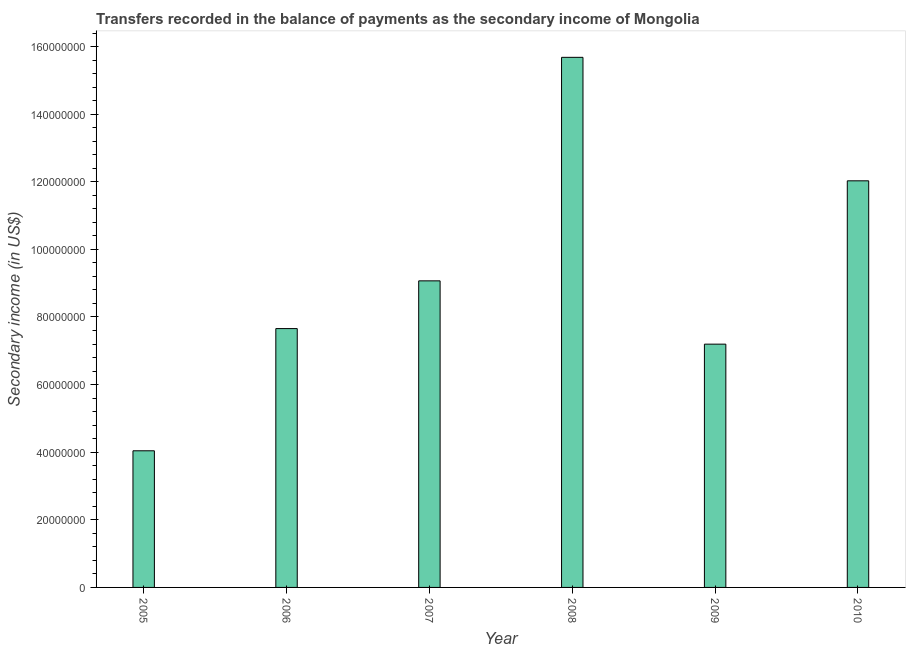Does the graph contain grids?
Provide a succinct answer. No. What is the title of the graph?
Keep it short and to the point. Transfers recorded in the balance of payments as the secondary income of Mongolia. What is the label or title of the X-axis?
Provide a succinct answer. Year. What is the label or title of the Y-axis?
Your answer should be very brief. Secondary income (in US$). What is the amount of secondary income in 2008?
Make the answer very short. 1.57e+08. Across all years, what is the maximum amount of secondary income?
Make the answer very short. 1.57e+08. Across all years, what is the minimum amount of secondary income?
Keep it short and to the point. 4.04e+07. In which year was the amount of secondary income maximum?
Give a very brief answer. 2008. In which year was the amount of secondary income minimum?
Your answer should be compact. 2005. What is the sum of the amount of secondary income?
Your answer should be compact. 5.57e+08. What is the difference between the amount of secondary income in 2005 and 2008?
Your answer should be very brief. -1.16e+08. What is the average amount of secondary income per year?
Keep it short and to the point. 9.28e+07. What is the median amount of secondary income?
Keep it short and to the point. 8.36e+07. Do a majority of the years between 2009 and 2007 (inclusive) have amount of secondary income greater than 40000000 US$?
Give a very brief answer. Yes. What is the ratio of the amount of secondary income in 2008 to that in 2010?
Provide a short and direct response. 1.3. Is the amount of secondary income in 2005 less than that in 2007?
Provide a succinct answer. Yes. Is the difference between the amount of secondary income in 2005 and 2006 greater than the difference between any two years?
Ensure brevity in your answer.  No. What is the difference between the highest and the second highest amount of secondary income?
Make the answer very short. 3.65e+07. What is the difference between the highest and the lowest amount of secondary income?
Keep it short and to the point. 1.16e+08. In how many years, is the amount of secondary income greater than the average amount of secondary income taken over all years?
Offer a terse response. 2. How many bars are there?
Make the answer very short. 6. Are all the bars in the graph horizontal?
Offer a very short reply. No. How many years are there in the graph?
Your answer should be compact. 6. Are the values on the major ticks of Y-axis written in scientific E-notation?
Keep it short and to the point. No. What is the Secondary income (in US$) in 2005?
Your response must be concise. 4.04e+07. What is the Secondary income (in US$) of 2006?
Offer a very short reply. 7.66e+07. What is the Secondary income (in US$) in 2007?
Make the answer very short. 9.07e+07. What is the Secondary income (in US$) in 2008?
Keep it short and to the point. 1.57e+08. What is the Secondary income (in US$) in 2009?
Make the answer very short. 7.20e+07. What is the Secondary income (in US$) of 2010?
Your answer should be compact. 1.20e+08. What is the difference between the Secondary income (in US$) in 2005 and 2006?
Your response must be concise. -3.62e+07. What is the difference between the Secondary income (in US$) in 2005 and 2007?
Offer a very short reply. -5.03e+07. What is the difference between the Secondary income (in US$) in 2005 and 2008?
Make the answer very short. -1.16e+08. What is the difference between the Secondary income (in US$) in 2005 and 2009?
Give a very brief answer. -3.15e+07. What is the difference between the Secondary income (in US$) in 2005 and 2010?
Offer a very short reply. -7.99e+07. What is the difference between the Secondary income (in US$) in 2006 and 2007?
Give a very brief answer. -1.41e+07. What is the difference between the Secondary income (in US$) in 2006 and 2008?
Provide a succinct answer. -8.02e+07. What is the difference between the Secondary income (in US$) in 2006 and 2009?
Keep it short and to the point. 4.60e+06. What is the difference between the Secondary income (in US$) in 2006 and 2010?
Ensure brevity in your answer.  -4.37e+07. What is the difference between the Secondary income (in US$) in 2007 and 2008?
Provide a succinct answer. -6.61e+07. What is the difference between the Secondary income (in US$) in 2007 and 2009?
Keep it short and to the point. 1.87e+07. What is the difference between the Secondary income (in US$) in 2007 and 2010?
Keep it short and to the point. -2.96e+07. What is the difference between the Secondary income (in US$) in 2008 and 2009?
Give a very brief answer. 8.48e+07. What is the difference between the Secondary income (in US$) in 2008 and 2010?
Keep it short and to the point. 3.65e+07. What is the difference between the Secondary income (in US$) in 2009 and 2010?
Give a very brief answer. -4.83e+07. What is the ratio of the Secondary income (in US$) in 2005 to that in 2006?
Ensure brevity in your answer.  0.53. What is the ratio of the Secondary income (in US$) in 2005 to that in 2007?
Your answer should be very brief. 0.45. What is the ratio of the Secondary income (in US$) in 2005 to that in 2008?
Keep it short and to the point. 0.26. What is the ratio of the Secondary income (in US$) in 2005 to that in 2009?
Keep it short and to the point. 0.56. What is the ratio of the Secondary income (in US$) in 2005 to that in 2010?
Offer a terse response. 0.34. What is the ratio of the Secondary income (in US$) in 2006 to that in 2007?
Your response must be concise. 0.84. What is the ratio of the Secondary income (in US$) in 2006 to that in 2008?
Offer a very short reply. 0.49. What is the ratio of the Secondary income (in US$) in 2006 to that in 2009?
Give a very brief answer. 1.06. What is the ratio of the Secondary income (in US$) in 2006 to that in 2010?
Keep it short and to the point. 0.64. What is the ratio of the Secondary income (in US$) in 2007 to that in 2008?
Provide a succinct answer. 0.58. What is the ratio of the Secondary income (in US$) in 2007 to that in 2009?
Make the answer very short. 1.26. What is the ratio of the Secondary income (in US$) in 2007 to that in 2010?
Give a very brief answer. 0.75. What is the ratio of the Secondary income (in US$) in 2008 to that in 2009?
Ensure brevity in your answer.  2.18. What is the ratio of the Secondary income (in US$) in 2008 to that in 2010?
Your response must be concise. 1.3. What is the ratio of the Secondary income (in US$) in 2009 to that in 2010?
Ensure brevity in your answer.  0.6. 